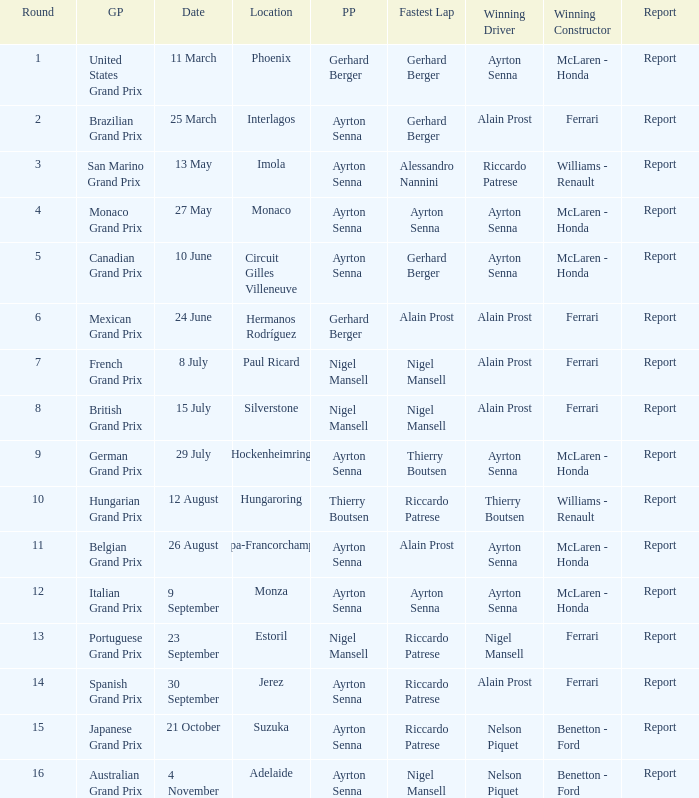What was the constructor when riccardo patrese was the winning driver? Williams - Renault. 